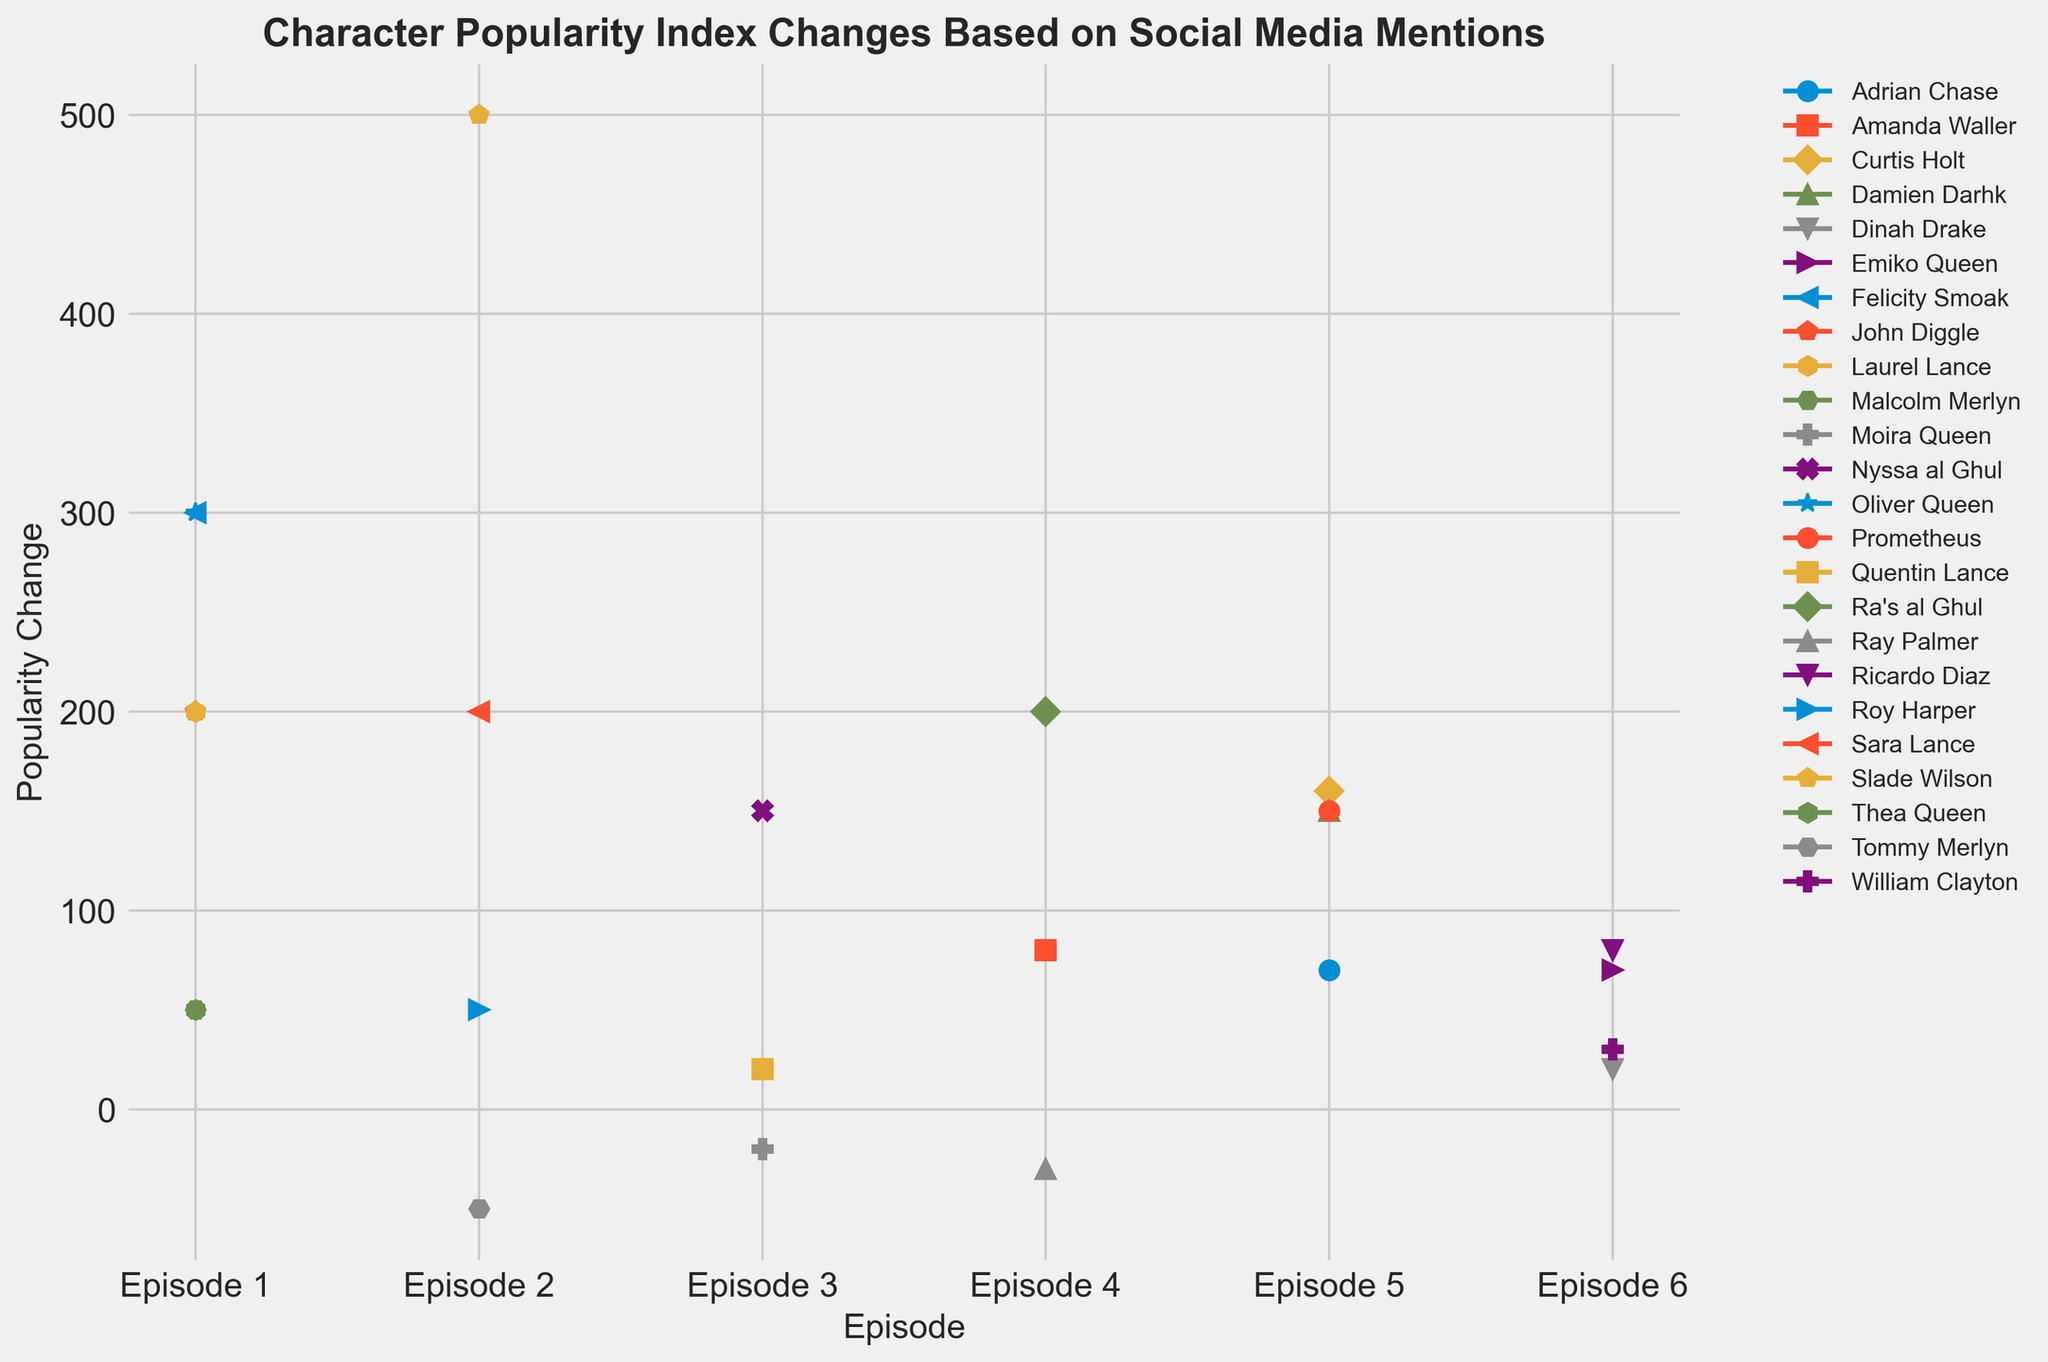What's the largest popularity change for any character throughout the episodes? To find the largest popularity change, you need to look at the line with the highest or lowest point on the chart. The highest point on the chart represents the largest positive change and is seen in Episode 2 for Slade Wilson with a change of 500.
Answer: 500 Which character had a negative popularity change in Episode 4? You can identify the character by looking at the line that dips below the horizontal axis in Episode 4. The lines for Ray Palmer show a negative change as it dips below 0.
Answer: Ray Palmer Who experienced the most significant improvement in popularity from Episode 1 to Episode 2? To determine this, compare the popularity changes of characters across these two episodes. Slade Wilson shows a drastic increase in Episode 2 with a change of 500, which is higher than any changes in Episode 1.
Answer: Slade Wilson Which character had the smallest positive change in popularity and in which episode? The smallest positive change can be identified by looking for the smallest value above the zero line. Thea Queen and Malcolm Merlyn have the smallest positive change of 50 in Episode 1 and Roy Harper has the same change in Episode 2.
Answer: Thea Queen, Malcolm Merlyn, Episode 1 or Roy Harper, Episode 2 Compare the popularity change of Oliver Queen in Episode 1 and Ra's al Ghul in Episode 4. Which one had a higher change? Compare the values for Oliver Queen in Episode 1 (300) and Ra's al Ghul in Episode 4 (200). Oliver Queen had a higher change in Episode 1.
Answer: Oliver Queen What is the average popularity change for characters in Episode 3? Sum up the popularity changes for Episode 3 and divide by the number of characters. The values are: Quentin Lance (20), Moira Queen (-20), Nyssa al Ghul (150). The total is 20 + (-20) + 150 = 150, then divide by 3: 150/3 = 50.
Answer: 50 Which episode had the highest cumulative popularity change for all characters? Add the popularity changes for all characters within each episode and compare. The sums are: Episode 1: 1100, Episode 2: 700, Episode 3: 150, Episode 4: 250, Episode 5: 680, Episode 6: 270. Episode 1 has the highest cumulative change of 1100.
Answer: Episode 1 How many characters experienced a negative popularity change throughout the entire dataset? Look at each episode and count the characters with negative values. Tommy Merlyn (Episode 2), Moira Queen (Episode 3), Ray Palmer (Episode 4): 3 characters in total.
Answer: 3 characters Which character showed a steady increase in popularity across all their episodes? Examine the lines that consistently rise without any dips across multiple episodes. Curtis Holt shows a steady increase in popularity in Episodes 5 and 6.
Answer: Curtis Holt Compare the overall popularity change for Oliver Queen and Felicity Smoak across all episodes. Who has a higher cumulative change? Sum up the popularity changes for Oliver Queen (300 in Episode 1) and Felicity Smoak (300 in Episode 1). Both have the same one value and don't appear in other episodes.
Answer: Equal 